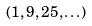Convert formula to latex. <formula><loc_0><loc_0><loc_500><loc_500>( 1 , 9 , 2 5 , \dots )</formula> 